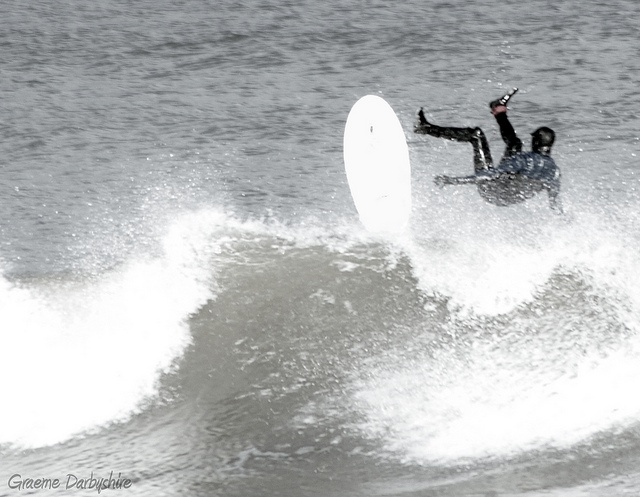Describe the objects in this image and their specific colors. I can see surfboard in darkgray, white, and lightgray tones and people in darkgray, gray, black, and lightgray tones in this image. 